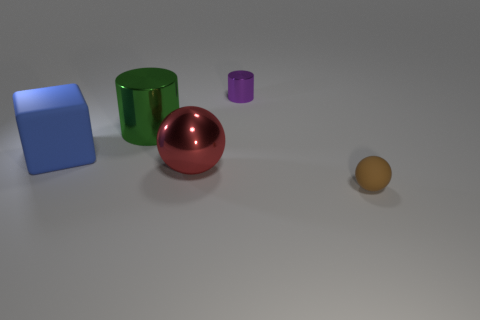Can you tell me what the materials of the objects in the image look like? Certainly, the items in the image display a variety of materials. The cube on the left seems to have a matte surface, likely representing a plastic or painted metal. The bigger cylinder in the middle shows a reflective metallic surface, suggesting it could be made of polished metal. Similarly, the tiny cylinder also has a metallic finish though it is smaller in size. The sphere in the center has a glossy, reflective surface indicative of a metallic material with a possibly chrome finish. Lastly, the small sphere on the right has a diffuse surface, hinting at a matte texture that could be of a material like clay or unpolished wood. 